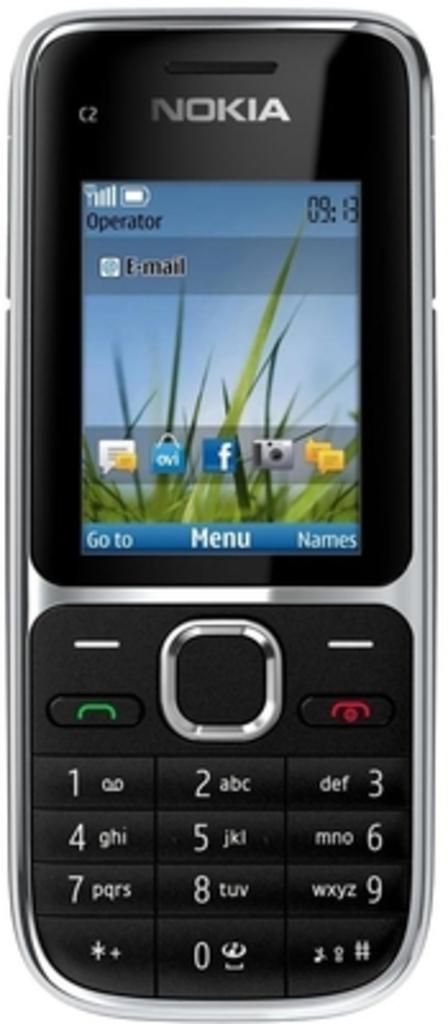What brand of phone is this?
Make the answer very short. Nokia. What phone type is this?
Offer a terse response. Nokia. 